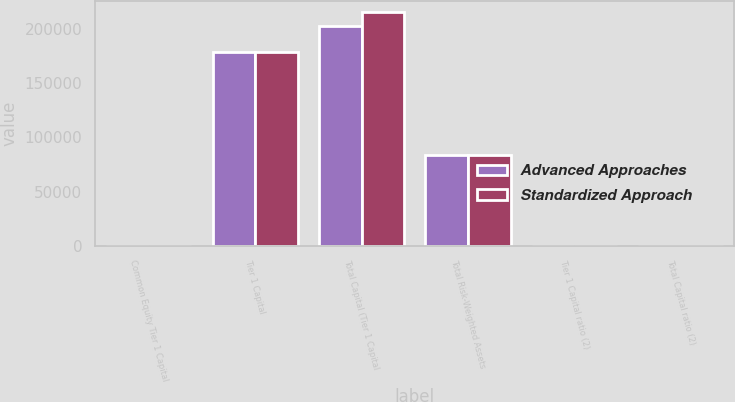<chart> <loc_0><loc_0><loc_500><loc_500><stacked_bar_chart><ecel><fcel>Common Equity Tier 1 Capital<fcel>Tier 1 Capital<fcel>Total Capital (Tier 1 Capital<fcel>Total Risk-Weighted Assets<fcel>Tier 1 Capital ratio (2)<fcel>Total Capital ratio (2)<nl><fcel>Advanced Approaches<fcel>14.35<fcel>178387<fcel>202146<fcel>83698.5<fcel>15.29<fcel>17.33<nl><fcel>Standardized Approach<fcel>14.86<fcel>178387<fcel>214938<fcel>83698.5<fcel>15.84<fcel>19.08<nl></chart> 